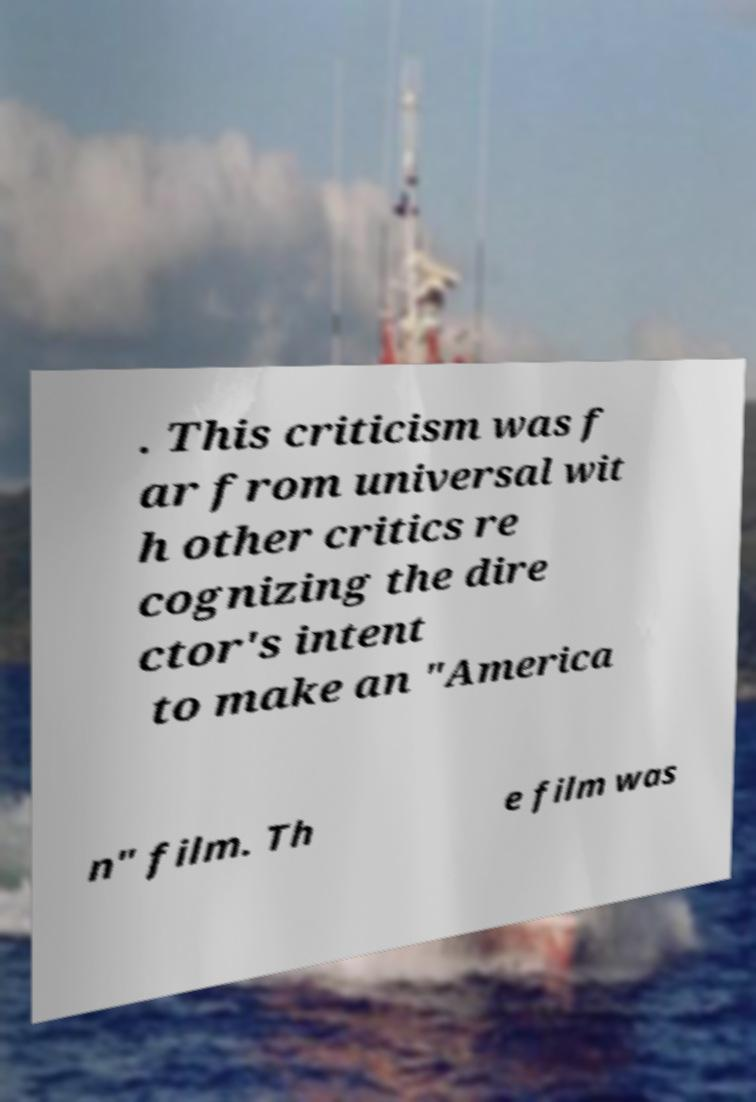What messages or text are displayed in this image? I need them in a readable, typed format. . This criticism was f ar from universal wit h other critics re cognizing the dire ctor's intent to make an "America n" film. Th e film was 